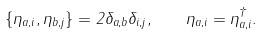<formula> <loc_0><loc_0><loc_500><loc_500>\{ \eta _ { a , i } , \eta _ { b , j } \} = 2 \delta _ { a , b } \delta _ { i , j } , \quad \eta _ { a , i } = \eta _ { a , i } ^ { \dagger } .</formula> 